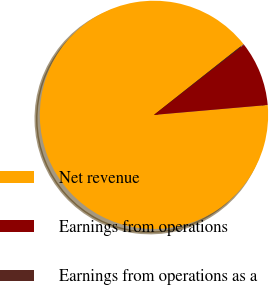Convert chart. <chart><loc_0><loc_0><loc_500><loc_500><pie_chart><fcel>Net revenue<fcel>Earnings from operations<fcel>Earnings from operations as a<nl><fcel>90.74%<fcel>9.16%<fcel>0.1%<nl></chart> 